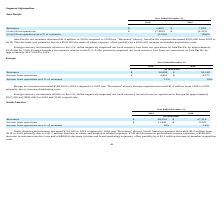From Travelzoo's financial document, What is the revenue amount in 2019 and 2018 respectively? The document shows two values: $36,898 and $36,149 (in thousands). From the document: "Revenues $ 36,898 $ 36,149 Revenues $ 36,898 $ 36,149..." Also, What is the income from operations in 2019 and 2018 respectively? The document shows two values: $4,461 and $4,973 (in thousands). From the document: "Income from operations $ 4,461 $ 4,973 Income from operations $ 4,461 $ 4,973..." Also, Why did Europe expenses increase from 2018 to 2019? primarily due to increased marketing costs. The document states: "primarily due to increased marketing costs...." Also, can you calculate: What is the average income from operations in 2018 and 2019? To answer this question, I need to perform calculations using the financial data. The calculation is: (4,461+ 4,973)/2, which equals 4717 (in thousands). This is based on the information: "Income from operations $ 4,461 $ 4,973 Income from operations $ 4,461 $ 4,973..." The key data points involved are: 4,461, 4,973. Also, can you calculate: What is the change in income from operations between 2018 and 2019? Based on the calculation: 4,461-4,973, the result is -512 (in thousands). This is based on the information: "Income from operations $ 4,461 $ 4,973 Income from operations $ 4,461 $ 4,973..." The key data points involved are: 4,461, 4,973. Also, can you calculate: What is the percentage change in revenues from 2018 to 2019? To answer this question, I need to perform calculations using the financial data. The calculation is: (36,898-36,149)/36,149, which equals 2.07 (percentage). This is based on the information: "Revenues $ 36,898 $ 36,149 Revenues $ 36,898 $ 36,149..." The key data points involved are: 36,149, 36,898. 